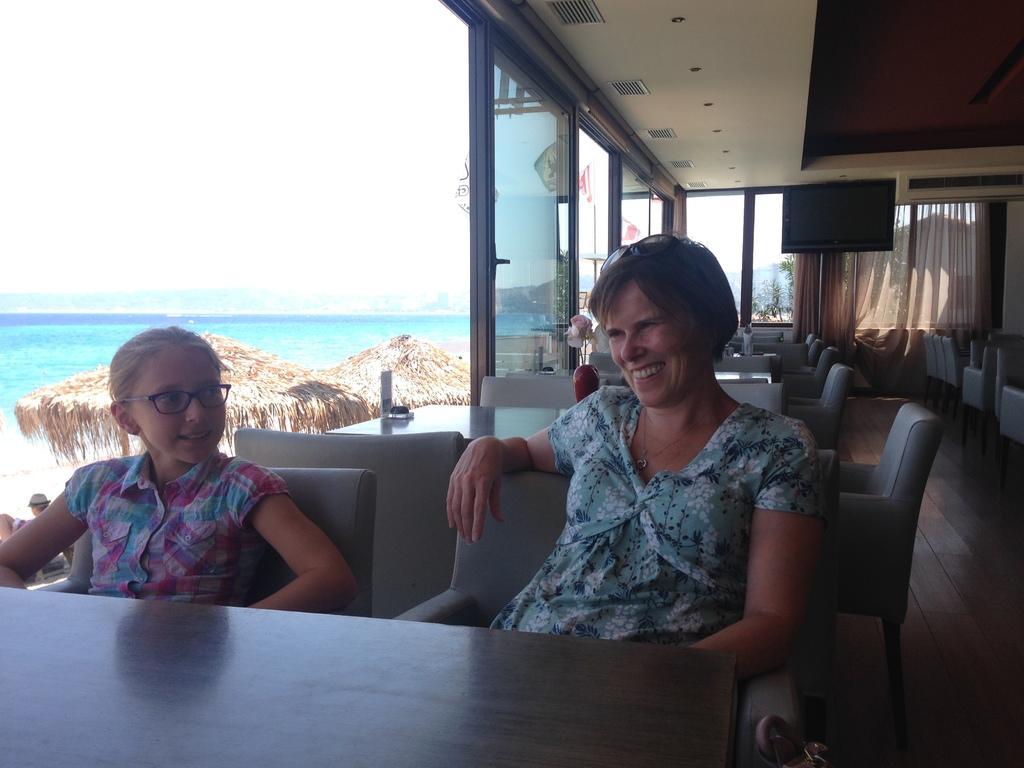Could you give a brief overview of what you see in this image? In this picture we can see woman and girl sitting on chair and they are smiling and in front of them on table we have vase with flower in it and in background we can see curtains to windows, water, huts, sky, television. 